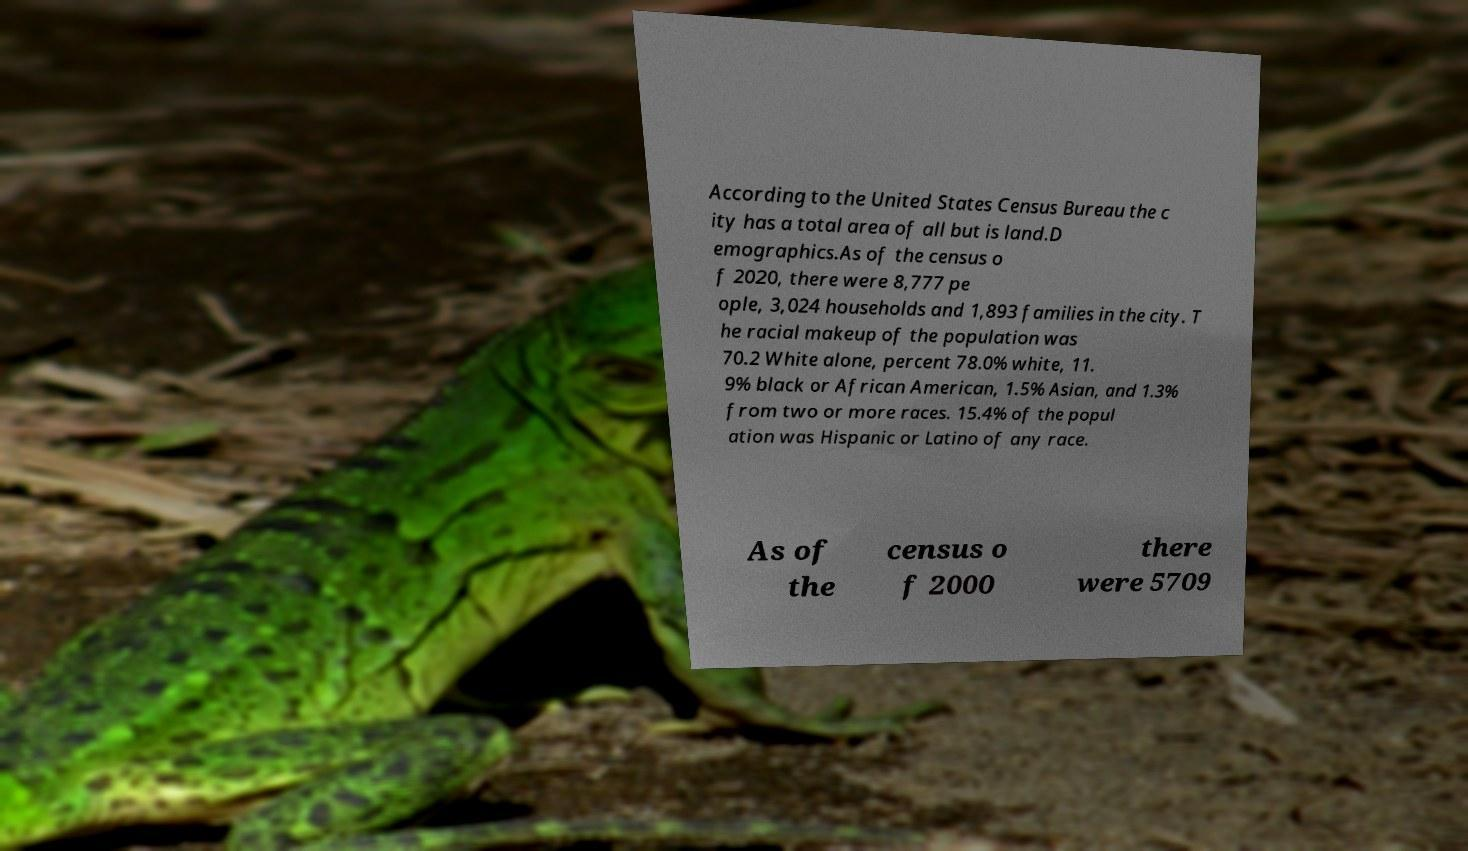I need the written content from this picture converted into text. Can you do that? According to the United States Census Bureau the c ity has a total area of all but is land.D emographics.As of the census o f 2020, there were 8,777 pe ople, 3,024 households and 1,893 families in the city. T he racial makeup of the population was 70.2 White alone, percent 78.0% white, 11. 9% black or African American, 1.5% Asian, and 1.3% from two or more races. 15.4% of the popul ation was Hispanic or Latino of any race. As of the census o f 2000 there were 5709 